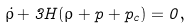Convert formula to latex. <formula><loc_0><loc_0><loc_500><loc_500>\dot { \rho } + 3 H ( \rho + p + p _ { c } ) = 0 ,</formula> 